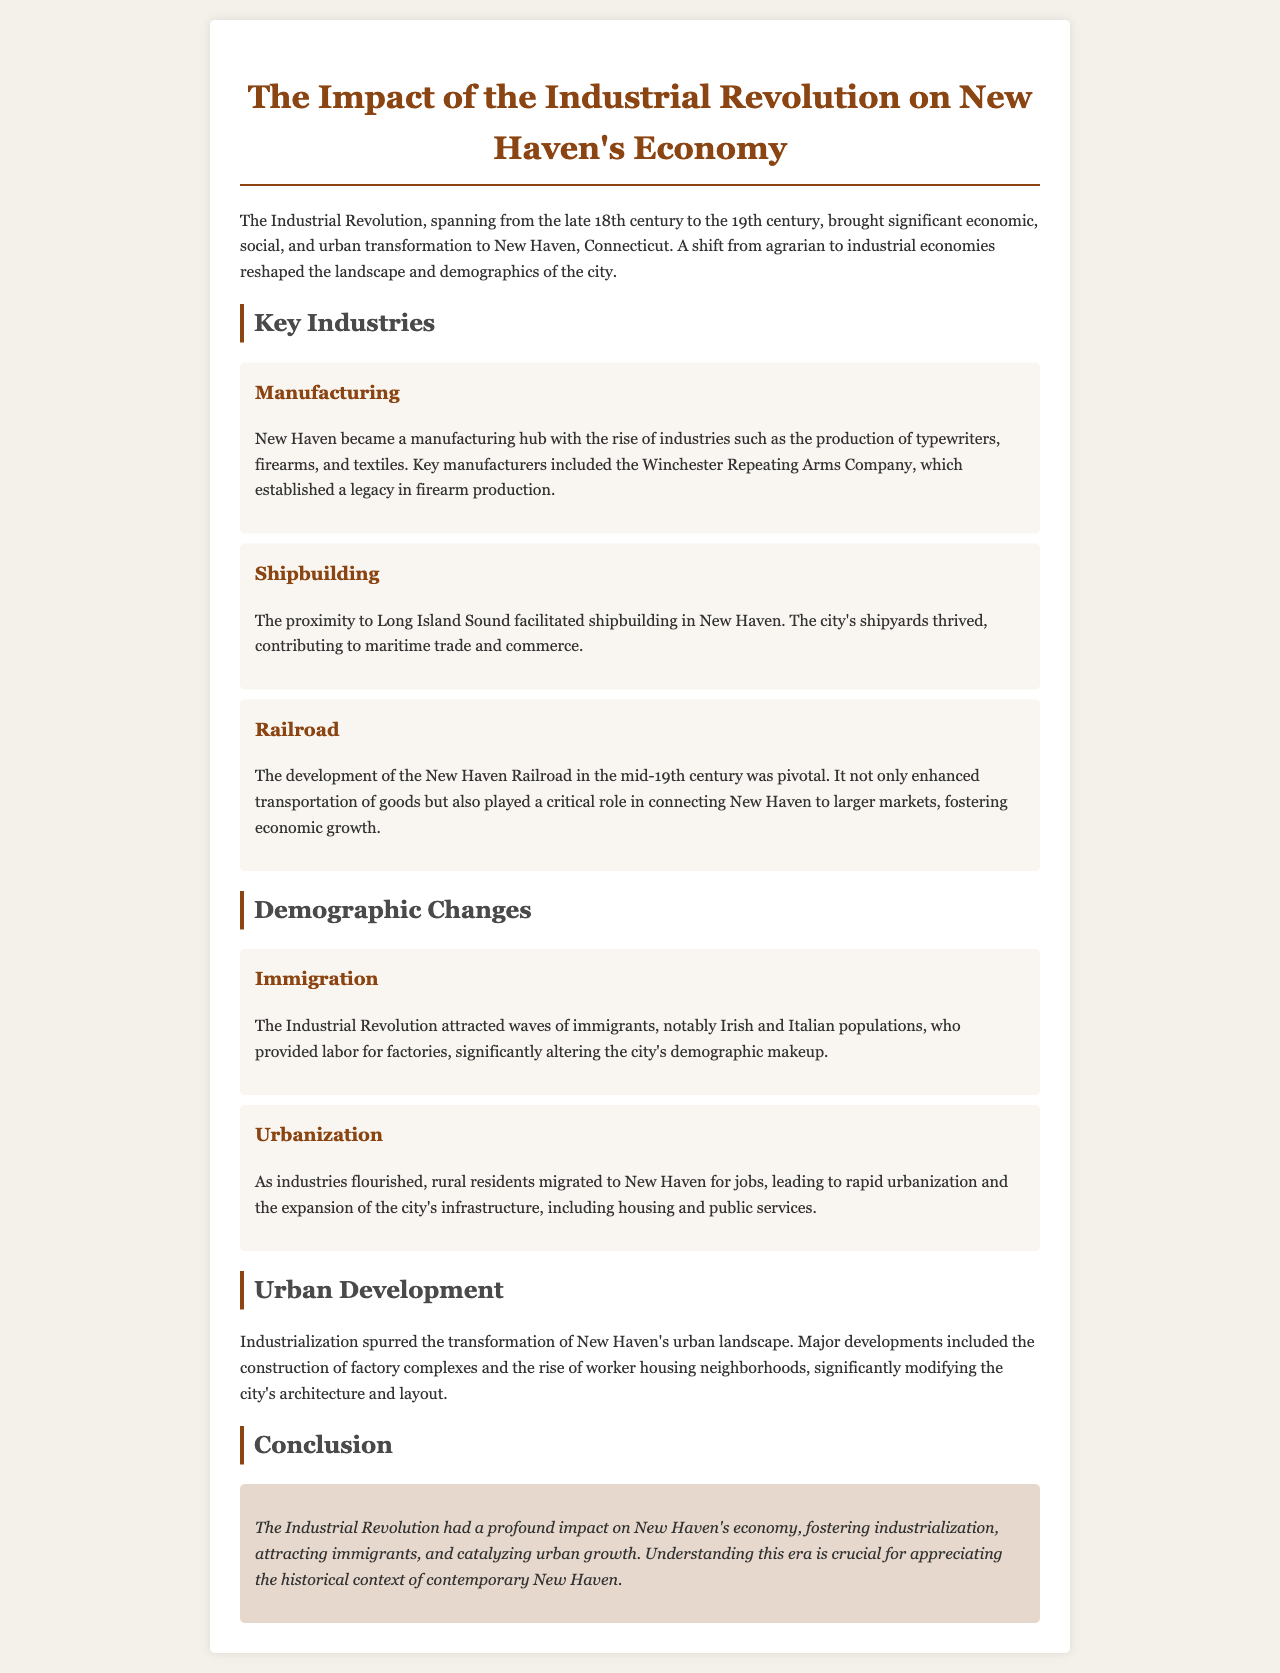What is a key manufacturing industry in New Haven? The document mentions the production of typewriters, firearms, and textiles as key manufacturing industries in New Haven, highlighting Winchester Repeating Arms Company in particular.
Answer: Winchester Repeating Arms Company Which body of water contributed to shipbuilding in New Haven? The proximity to Long Island Sound is noted as a facilitating factor for shipbuilding in New Haven.
Answer: Long Island Sound What was a major transportation development in the mid-19th century? The document states that the development of the New Haven Railroad was pivotal in enhancing transportation of goods.
Answer: New Haven Railroad Which immigrant groups significantly altered New Haven's demographics? The document identifies Irish and Italian populations as the notable immigrant groups that provided labor for factories.
Answer: Irish and Italian What drove the rapid urbanization in New Haven? The document indicates that rural residents migrated to New Haven for jobs as industries flourished, leading to urbanization.
Answer: Jobs What type of housing developed as a result of industrialization? The report highlights the rise of worker housing neighborhoods as a consequence of industrialization and urban growth in New Haven.
Answer: Worker housing neighborhoods How did industrialization impact the urban landscape of New Haven? The document discusses the construction of factory complexes and changes in housing as part of the urban transformation spurred by industrialization.
Answer: Factory complexes and housing What is the time span of the Industrial Revolution discussed in the document? The document specifies that the Industrial Revolution spanned from the late 18th century to the 19th century.
Answer: Late 18th century to 19th century 